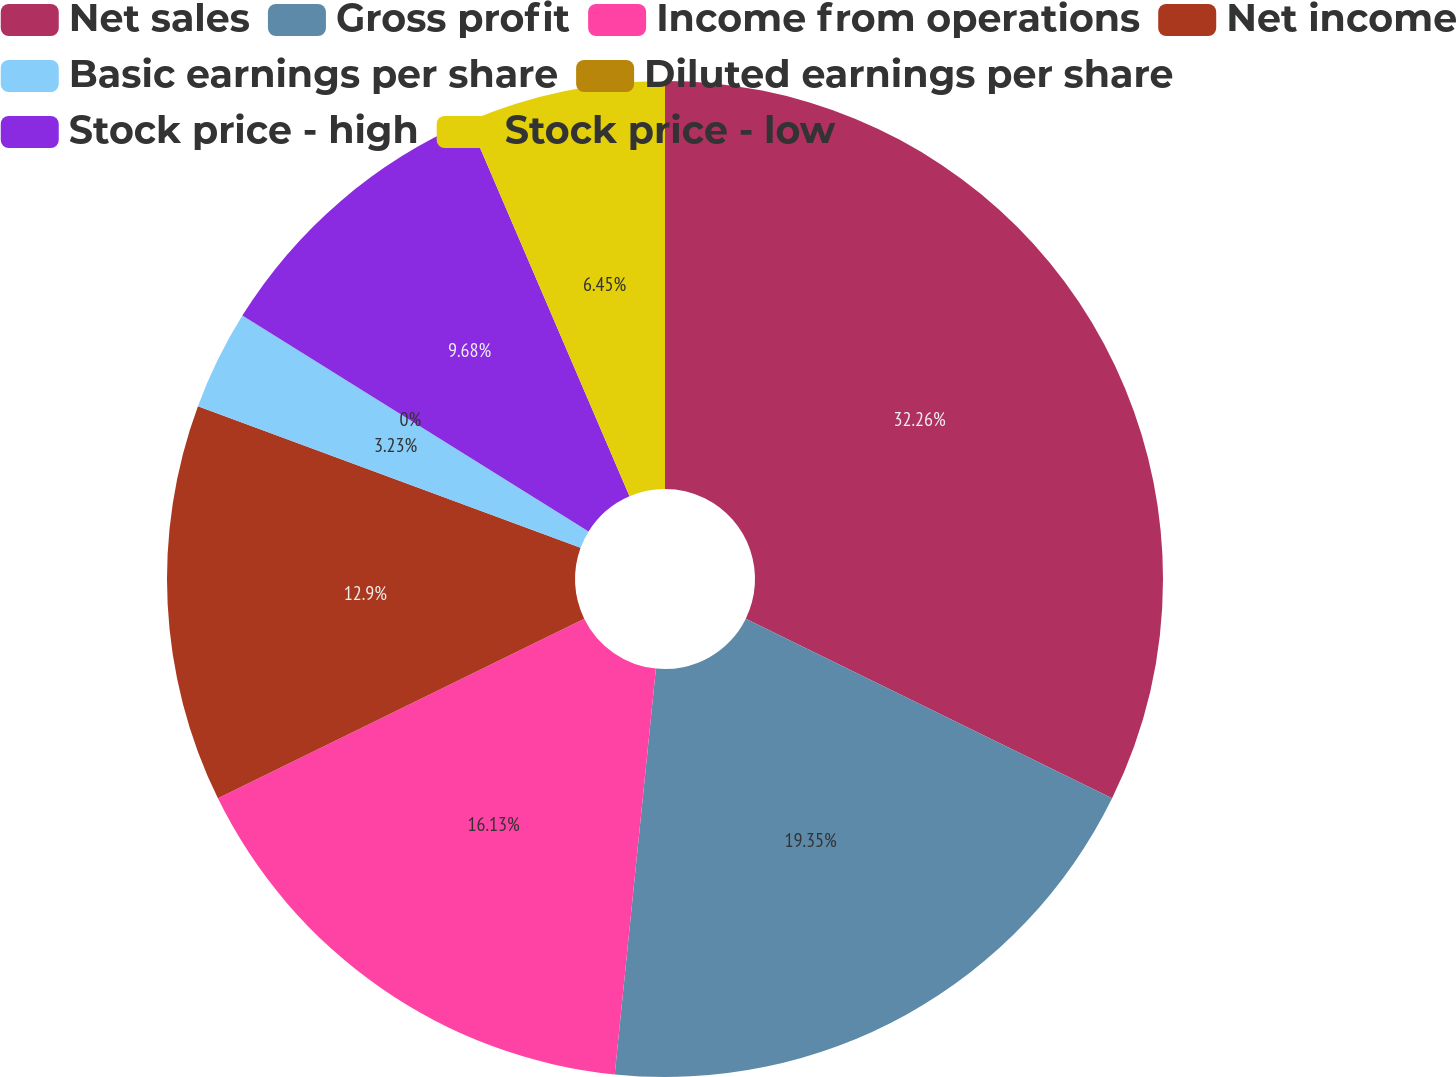Convert chart to OTSL. <chart><loc_0><loc_0><loc_500><loc_500><pie_chart><fcel>Net sales<fcel>Gross profit<fcel>Income from operations<fcel>Net income<fcel>Basic earnings per share<fcel>Diluted earnings per share<fcel>Stock price - high<fcel>Stock price - low<nl><fcel>32.26%<fcel>19.35%<fcel>16.13%<fcel>12.9%<fcel>3.23%<fcel>0.0%<fcel>9.68%<fcel>6.45%<nl></chart> 